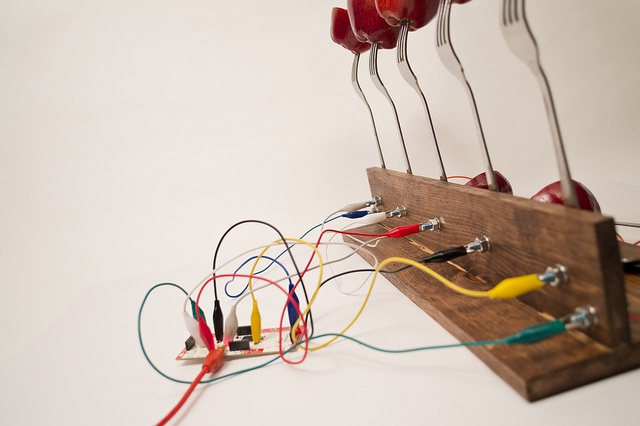Describe the objects in this image and their specific colors. I can see fork in lightgray, tan, darkgray, and gray tones, apple in lightgray, maroon, brown, and tan tones, fork in lightgray, darkgray, and gray tones, fork in lightgray, darkgray, and gray tones, and apple in lightgray, maroon, and brown tones in this image. 